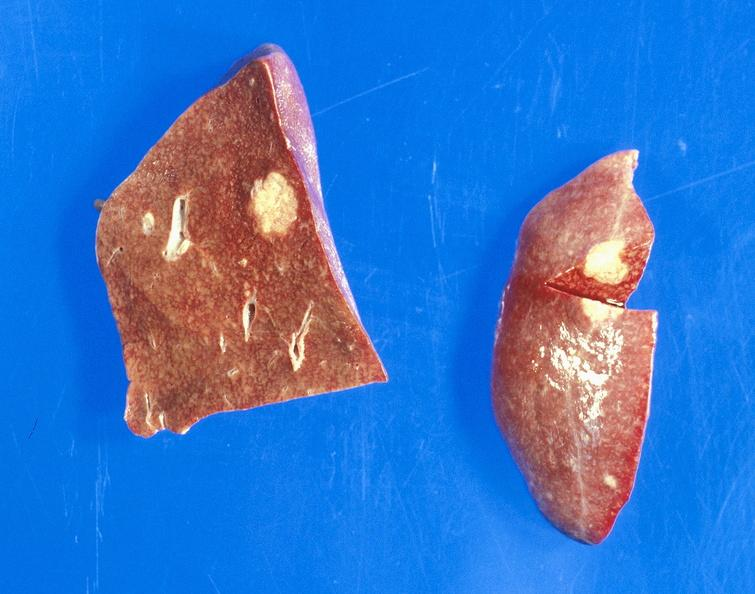what does this image show?
Answer the question using a single word or phrase. Bronchiogenic carcinoma 